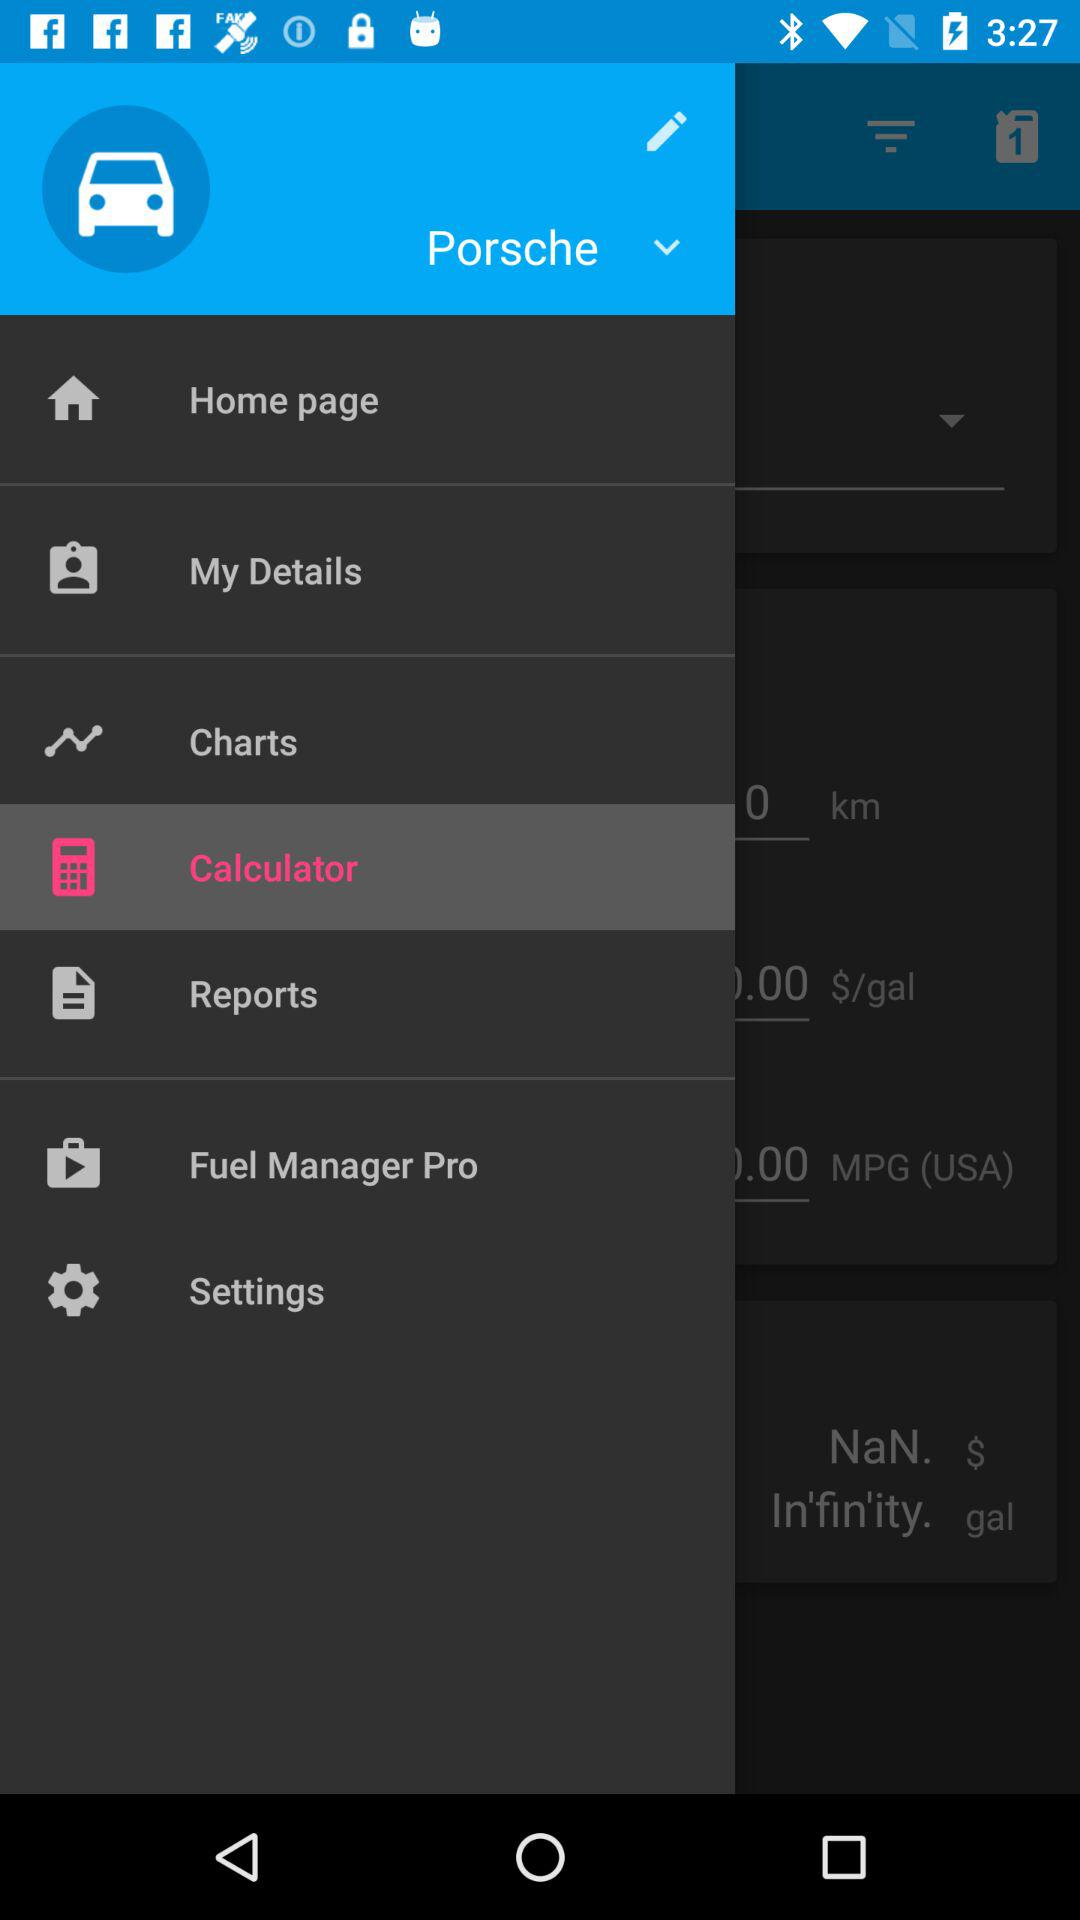Which option is selected? The selected option is "Porsche". 